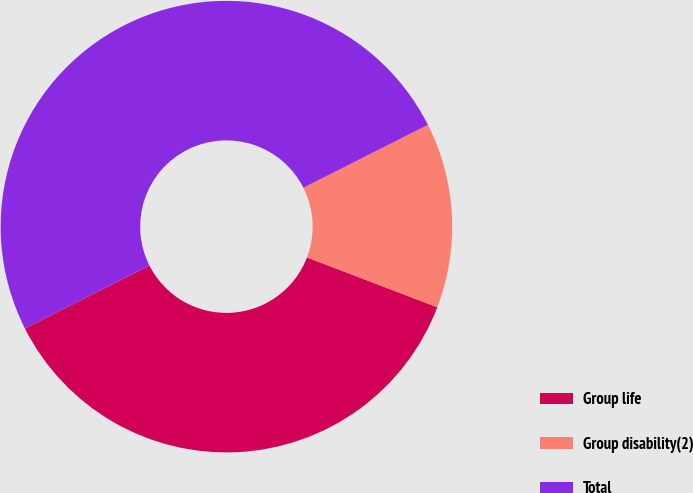Convert chart to OTSL. <chart><loc_0><loc_0><loc_500><loc_500><pie_chart><fcel>Group life<fcel>Group disability(2)<fcel>Total<nl><fcel>36.74%<fcel>13.26%<fcel>50.0%<nl></chart> 